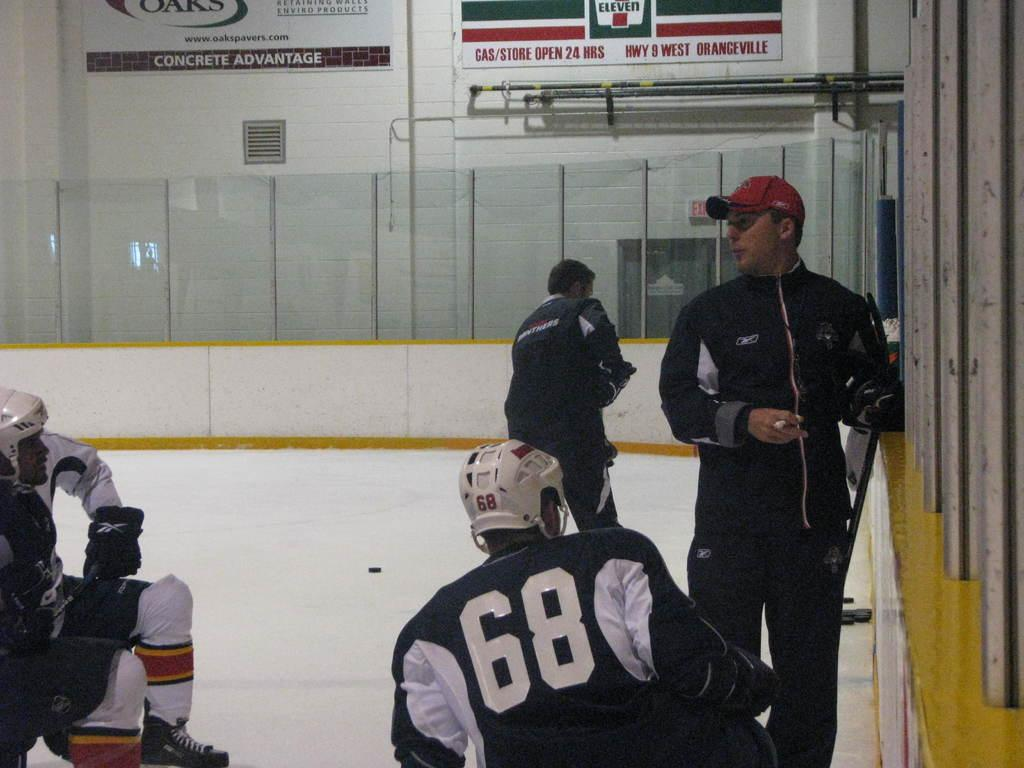Provide a one-sentence caption for the provided image. Hockey players are on the ice in an arena that features an advertisement for 7 Eleven. 